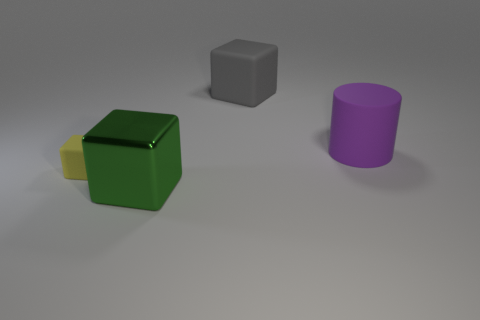Are there any other things that are the same size as the yellow thing?
Provide a short and direct response. No. What is the color of the other matte object that is the same size as the gray matte object?
Provide a succinct answer. Purple. There is a object left of the block that is in front of the rubber object that is to the left of the green thing; what is its shape?
Make the answer very short. Cube. How many things are either purple rubber objects or large objects behind the green shiny thing?
Provide a short and direct response. 2. There is a rubber cube that is right of the green object; is it the same size as the green shiny object?
Your answer should be compact. Yes. There is a block that is on the right side of the big green cube; what is it made of?
Your answer should be compact. Rubber. Is the number of big purple matte objects that are on the left side of the big rubber cylinder the same as the number of big shiny things that are behind the tiny yellow matte object?
Your response must be concise. Yes. There is a big rubber thing that is the same shape as the tiny matte object; what color is it?
Give a very brief answer. Gray. Is there anything else that has the same color as the cylinder?
Your response must be concise. No. How many rubber things are red balls or tiny cubes?
Offer a terse response. 1. 